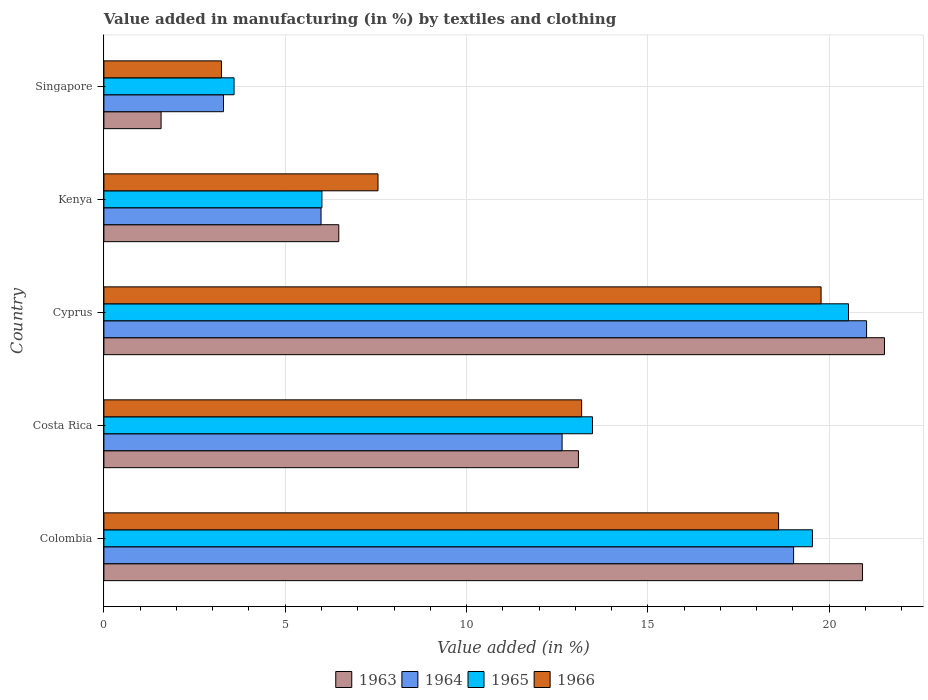How many groups of bars are there?
Your answer should be very brief. 5. Are the number of bars per tick equal to the number of legend labels?
Offer a terse response. Yes. Are the number of bars on each tick of the Y-axis equal?
Provide a succinct answer. Yes. How many bars are there on the 1st tick from the bottom?
Provide a succinct answer. 4. What is the label of the 3rd group of bars from the top?
Offer a terse response. Cyprus. What is the percentage of value added in manufacturing by textiles and clothing in 1966 in Cyprus?
Offer a terse response. 19.78. Across all countries, what is the maximum percentage of value added in manufacturing by textiles and clothing in 1965?
Your answer should be very brief. 20.53. Across all countries, what is the minimum percentage of value added in manufacturing by textiles and clothing in 1963?
Make the answer very short. 1.58. In which country was the percentage of value added in manufacturing by textiles and clothing in 1963 maximum?
Your answer should be very brief. Cyprus. In which country was the percentage of value added in manufacturing by textiles and clothing in 1965 minimum?
Make the answer very short. Singapore. What is the total percentage of value added in manufacturing by textiles and clothing in 1966 in the graph?
Your answer should be very brief. 62.35. What is the difference between the percentage of value added in manufacturing by textiles and clothing in 1965 in Costa Rica and that in Cyprus?
Keep it short and to the point. -7.06. What is the difference between the percentage of value added in manufacturing by textiles and clothing in 1966 in Kenya and the percentage of value added in manufacturing by textiles and clothing in 1965 in Cyprus?
Provide a short and direct response. -12.97. What is the average percentage of value added in manufacturing by textiles and clothing in 1963 per country?
Your response must be concise. 12.72. What is the difference between the percentage of value added in manufacturing by textiles and clothing in 1963 and percentage of value added in manufacturing by textiles and clothing in 1966 in Singapore?
Make the answer very short. -1.66. In how many countries, is the percentage of value added in manufacturing by textiles and clothing in 1966 greater than 20 %?
Offer a terse response. 0. What is the ratio of the percentage of value added in manufacturing by textiles and clothing in 1963 in Colombia to that in Cyprus?
Your answer should be compact. 0.97. Is the percentage of value added in manufacturing by textiles and clothing in 1966 in Cyprus less than that in Kenya?
Make the answer very short. No. Is the difference between the percentage of value added in manufacturing by textiles and clothing in 1963 in Costa Rica and Singapore greater than the difference between the percentage of value added in manufacturing by textiles and clothing in 1966 in Costa Rica and Singapore?
Give a very brief answer. Yes. What is the difference between the highest and the second highest percentage of value added in manufacturing by textiles and clothing in 1963?
Provide a succinct answer. 0.61. What is the difference between the highest and the lowest percentage of value added in manufacturing by textiles and clothing in 1963?
Offer a very short reply. 19.95. In how many countries, is the percentage of value added in manufacturing by textiles and clothing in 1964 greater than the average percentage of value added in manufacturing by textiles and clothing in 1964 taken over all countries?
Give a very brief answer. 3. What does the 3rd bar from the top in Kenya represents?
Offer a terse response. 1964. What does the 2nd bar from the bottom in Kenya represents?
Ensure brevity in your answer.  1964. How many bars are there?
Provide a succinct answer. 20. How many countries are there in the graph?
Make the answer very short. 5. What is the difference between two consecutive major ticks on the X-axis?
Provide a succinct answer. 5. Are the values on the major ticks of X-axis written in scientific E-notation?
Offer a very short reply. No. Does the graph contain any zero values?
Offer a very short reply. No. Where does the legend appear in the graph?
Offer a very short reply. Bottom center. How many legend labels are there?
Provide a short and direct response. 4. How are the legend labels stacked?
Offer a terse response. Horizontal. What is the title of the graph?
Your answer should be very brief. Value added in manufacturing (in %) by textiles and clothing. Does "1990" appear as one of the legend labels in the graph?
Your answer should be very brief. No. What is the label or title of the X-axis?
Provide a short and direct response. Value added (in %). What is the label or title of the Y-axis?
Your response must be concise. Country. What is the Value added (in %) of 1963 in Colombia?
Offer a very short reply. 20.92. What is the Value added (in %) in 1964 in Colombia?
Offer a terse response. 19.02. What is the Value added (in %) of 1965 in Colombia?
Make the answer very short. 19.54. What is the Value added (in %) in 1966 in Colombia?
Give a very brief answer. 18.6. What is the Value added (in %) of 1963 in Costa Rica?
Your answer should be compact. 13.08. What is the Value added (in %) in 1964 in Costa Rica?
Ensure brevity in your answer.  12.63. What is the Value added (in %) in 1965 in Costa Rica?
Provide a short and direct response. 13.47. What is the Value added (in %) of 1966 in Costa Rica?
Offer a terse response. 13.17. What is the Value added (in %) of 1963 in Cyprus?
Keep it short and to the point. 21.52. What is the Value added (in %) in 1964 in Cyprus?
Make the answer very short. 21.03. What is the Value added (in %) in 1965 in Cyprus?
Give a very brief answer. 20.53. What is the Value added (in %) in 1966 in Cyprus?
Ensure brevity in your answer.  19.78. What is the Value added (in %) in 1963 in Kenya?
Provide a succinct answer. 6.48. What is the Value added (in %) in 1964 in Kenya?
Offer a very short reply. 5.99. What is the Value added (in %) in 1965 in Kenya?
Your response must be concise. 6.01. What is the Value added (in %) of 1966 in Kenya?
Make the answer very short. 7.56. What is the Value added (in %) of 1963 in Singapore?
Keep it short and to the point. 1.58. What is the Value added (in %) in 1964 in Singapore?
Provide a succinct answer. 3.3. What is the Value added (in %) in 1965 in Singapore?
Provide a succinct answer. 3.59. What is the Value added (in %) in 1966 in Singapore?
Make the answer very short. 3.24. Across all countries, what is the maximum Value added (in %) of 1963?
Provide a succinct answer. 21.52. Across all countries, what is the maximum Value added (in %) in 1964?
Make the answer very short. 21.03. Across all countries, what is the maximum Value added (in %) of 1965?
Offer a very short reply. 20.53. Across all countries, what is the maximum Value added (in %) of 1966?
Your response must be concise. 19.78. Across all countries, what is the minimum Value added (in %) of 1963?
Give a very brief answer. 1.58. Across all countries, what is the minimum Value added (in %) in 1964?
Give a very brief answer. 3.3. Across all countries, what is the minimum Value added (in %) in 1965?
Keep it short and to the point. 3.59. Across all countries, what is the minimum Value added (in %) in 1966?
Provide a short and direct response. 3.24. What is the total Value added (in %) of 1963 in the graph?
Make the answer very short. 63.58. What is the total Value added (in %) of 1964 in the graph?
Your answer should be very brief. 61.97. What is the total Value added (in %) of 1965 in the graph?
Make the answer very short. 63.14. What is the total Value added (in %) of 1966 in the graph?
Give a very brief answer. 62.35. What is the difference between the Value added (in %) of 1963 in Colombia and that in Costa Rica?
Keep it short and to the point. 7.83. What is the difference between the Value added (in %) in 1964 in Colombia and that in Costa Rica?
Your answer should be compact. 6.38. What is the difference between the Value added (in %) of 1965 in Colombia and that in Costa Rica?
Your answer should be very brief. 6.06. What is the difference between the Value added (in %) of 1966 in Colombia and that in Costa Rica?
Give a very brief answer. 5.43. What is the difference between the Value added (in %) of 1963 in Colombia and that in Cyprus?
Your answer should be compact. -0.61. What is the difference between the Value added (in %) in 1964 in Colombia and that in Cyprus?
Your response must be concise. -2.01. What is the difference between the Value added (in %) of 1965 in Colombia and that in Cyprus?
Offer a terse response. -0.99. What is the difference between the Value added (in %) in 1966 in Colombia and that in Cyprus?
Your answer should be compact. -1.17. What is the difference between the Value added (in %) of 1963 in Colombia and that in Kenya?
Offer a very short reply. 14.44. What is the difference between the Value added (in %) in 1964 in Colombia and that in Kenya?
Offer a very short reply. 13.03. What is the difference between the Value added (in %) of 1965 in Colombia and that in Kenya?
Provide a succinct answer. 13.53. What is the difference between the Value added (in %) of 1966 in Colombia and that in Kenya?
Ensure brevity in your answer.  11.05. What is the difference between the Value added (in %) of 1963 in Colombia and that in Singapore?
Your response must be concise. 19.34. What is the difference between the Value added (in %) in 1964 in Colombia and that in Singapore?
Offer a very short reply. 15.72. What is the difference between the Value added (in %) of 1965 in Colombia and that in Singapore?
Provide a short and direct response. 15.95. What is the difference between the Value added (in %) of 1966 in Colombia and that in Singapore?
Keep it short and to the point. 15.36. What is the difference between the Value added (in %) in 1963 in Costa Rica and that in Cyprus?
Your response must be concise. -8.44. What is the difference between the Value added (in %) of 1964 in Costa Rica and that in Cyprus?
Provide a succinct answer. -8.4. What is the difference between the Value added (in %) of 1965 in Costa Rica and that in Cyprus?
Your answer should be very brief. -7.06. What is the difference between the Value added (in %) of 1966 in Costa Rica and that in Cyprus?
Give a very brief answer. -6.6. What is the difference between the Value added (in %) in 1963 in Costa Rica and that in Kenya?
Your answer should be compact. 6.61. What is the difference between the Value added (in %) of 1964 in Costa Rica and that in Kenya?
Your answer should be compact. 6.65. What is the difference between the Value added (in %) in 1965 in Costa Rica and that in Kenya?
Keep it short and to the point. 7.46. What is the difference between the Value added (in %) in 1966 in Costa Rica and that in Kenya?
Give a very brief answer. 5.62. What is the difference between the Value added (in %) in 1963 in Costa Rica and that in Singapore?
Keep it short and to the point. 11.51. What is the difference between the Value added (in %) of 1964 in Costa Rica and that in Singapore?
Offer a terse response. 9.34. What is the difference between the Value added (in %) in 1965 in Costa Rica and that in Singapore?
Your answer should be compact. 9.88. What is the difference between the Value added (in %) in 1966 in Costa Rica and that in Singapore?
Make the answer very short. 9.93. What is the difference between the Value added (in %) in 1963 in Cyprus and that in Kenya?
Offer a terse response. 15.05. What is the difference between the Value added (in %) in 1964 in Cyprus and that in Kenya?
Keep it short and to the point. 15.04. What is the difference between the Value added (in %) in 1965 in Cyprus and that in Kenya?
Provide a succinct answer. 14.52. What is the difference between the Value added (in %) of 1966 in Cyprus and that in Kenya?
Keep it short and to the point. 12.22. What is the difference between the Value added (in %) of 1963 in Cyprus and that in Singapore?
Offer a very short reply. 19.95. What is the difference between the Value added (in %) in 1964 in Cyprus and that in Singapore?
Offer a very short reply. 17.73. What is the difference between the Value added (in %) of 1965 in Cyprus and that in Singapore?
Provide a succinct answer. 16.94. What is the difference between the Value added (in %) in 1966 in Cyprus and that in Singapore?
Your answer should be compact. 16.53. What is the difference between the Value added (in %) of 1963 in Kenya and that in Singapore?
Provide a short and direct response. 4.9. What is the difference between the Value added (in %) of 1964 in Kenya and that in Singapore?
Give a very brief answer. 2.69. What is the difference between the Value added (in %) of 1965 in Kenya and that in Singapore?
Make the answer very short. 2.42. What is the difference between the Value added (in %) of 1966 in Kenya and that in Singapore?
Ensure brevity in your answer.  4.32. What is the difference between the Value added (in %) of 1963 in Colombia and the Value added (in %) of 1964 in Costa Rica?
Give a very brief answer. 8.28. What is the difference between the Value added (in %) in 1963 in Colombia and the Value added (in %) in 1965 in Costa Rica?
Your answer should be very brief. 7.44. What is the difference between the Value added (in %) of 1963 in Colombia and the Value added (in %) of 1966 in Costa Rica?
Give a very brief answer. 7.74. What is the difference between the Value added (in %) of 1964 in Colombia and the Value added (in %) of 1965 in Costa Rica?
Offer a terse response. 5.55. What is the difference between the Value added (in %) in 1964 in Colombia and the Value added (in %) in 1966 in Costa Rica?
Your response must be concise. 5.84. What is the difference between the Value added (in %) of 1965 in Colombia and the Value added (in %) of 1966 in Costa Rica?
Provide a succinct answer. 6.36. What is the difference between the Value added (in %) of 1963 in Colombia and the Value added (in %) of 1964 in Cyprus?
Your answer should be very brief. -0.11. What is the difference between the Value added (in %) in 1963 in Colombia and the Value added (in %) in 1965 in Cyprus?
Make the answer very short. 0.39. What is the difference between the Value added (in %) in 1963 in Colombia and the Value added (in %) in 1966 in Cyprus?
Keep it short and to the point. 1.14. What is the difference between the Value added (in %) in 1964 in Colombia and the Value added (in %) in 1965 in Cyprus?
Provide a succinct answer. -1.51. What is the difference between the Value added (in %) in 1964 in Colombia and the Value added (in %) in 1966 in Cyprus?
Offer a very short reply. -0.76. What is the difference between the Value added (in %) of 1965 in Colombia and the Value added (in %) of 1966 in Cyprus?
Provide a succinct answer. -0.24. What is the difference between the Value added (in %) of 1963 in Colombia and the Value added (in %) of 1964 in Kenya?
Offer a terse response. 14.93. What is the difference between the Value added (in %) of 1963 in Colombia and the Value added (in %) of 1965 in Kenya?
Provide a succinct answer. 14.91. What is the difference between the Value added (in %) in 1963 in Colombia and the Value added (in %) in 1966 in Kenya?
Offer a very short reply. 13.36. What is the difference between the Value added (in %) in 1964 in Colombia and the Value added (in %) in 1965 in Kenya?
Give a very brief answer. 13.01. What is the difference between the Value added (in %) of 1964 in Colombia and the Value added (in %) of 1966 in Kenya?
Offer a very short reply. 11.46. What is the difference between the Value added (in %) in 1965 in Colombia and the Value added (in %) in 1966 in Kenya?
Offer a very short reply. 11.98. What is the difference between the Value added (in %) of 1963 in Colombia and the Value added (in %) of 1964 in Singapore?
Provide a short and direct response. 17.62. What is the difference between the Value added (in %) of 1963 in Colombia and the Value added (in %) of 1965 in Singapore?
Make the answer very short. 17.33. What is the difference between the Value added (in %) of 1963 in Colombia and the Value added (in %) of 1966 in Singapore?
Provide a succinct answer. 17.68. What is the difference between the Value added (in %) in 1964 in Colombia and the Value added (in %) in 1965 in Singapore?
Make the answer very short. 15.43. What is the difference between the Value added (in %) in 1964 in Colombia and the Value added (in %) in 1966 in Singapore?
Provide a short and direct response. 15.78. What is the difference between the Value added (in %) in 1965 in Colombia and the Value added (in %) in 1966 in Singapore?
Offer a terse response. 16.3. What is the difference between the Value added (in %) in 1963 in Costa Rica and the Value added (in %) in 1964 in Cyprus?
Offer a terse response. -7.95. What is the difference between the Value added (in %) in 1963 in Costa Rica and the Value added (in %) in 1965 in Cyprus?
Keep it short and to the point. -7.45. What is the difference between the Value added (in %) in 1963 in Costa Rica and the Value added (in %) in 1966 in Cyprus?
Ensure brevity in your answer.  -6.69. What is the difference between the Value added (in %) of 1964 in Costa Rica and the Value added (in %) of 1965 in Cyprus?
Provide a succinct answer. -7.9. What is the difference between the Value added (in %) of 1964 in Costa Rica and the Value added (in %) of 1966 in Cyprus?
Your response must be concise. -7.14. What is the difference between the Value added (in %) of 1965 in Costa Rica and the Value added (in %) of 1966 in Cyprus?
Your answer should be compact. -6.3. What is the difference between the Value added (in %) of 1963 in Costa Rica and the Value added (in %) of 1964 in Kenya?
Offer a terse response. 7.1. What is the difference between the Value added (in %) of 1963 in Costa Rica and the Value added (in %) of 1965 in Kenya?
Give a very brief answer. 7.07. What is the difference between the Value added (in %) of 1963 in Costa Rica and the Value added (in %) of 1966 in Kenya?
Provide a succinct answer. 5.53. What is the difference between the Value added (in %) in 1964 in Costa Rica and the Value added (in %) in 1965 in Kenya?
Provide a succinct answer. 6.62. What is the difference between the Value added (in %) in 1964 in Costa Rica and the Value added (in %) in 1966 in Kenya?
Your response must be concise. 5.08. What is the difference between the Value added (in %) of 1965 in Costa Rica and the Value added (in %) of 1966 in Kenya?
Keep it short and to the point. 5.91. What is the difference between the Value added (in %) in 1963 in Costa Rica and the Value added (in %) in 1964 in Singapore?
Ensure brevity in your answer.  9.79. What is the difference between the Value added (in %) in 1963 in Costa Rica and the Value added (in %) in 1965 in Singapore?
Your answer should be very brief. 9.5. What is the difference between the Value added (in %) in 1963 in Costa Rica and the Value added (in %) in 1966 in Singapore?
Provide a short and direct response. 9.84. What is the difference between the Value added (in %) in 1964 in Costa Rica and the Value added (in %) in 1965 in Singapore?
Ensure brevity in your answer.  9.04. What is the difference between the Value added (in %) of 1964 in Costa Rica and the Value added (in %) of 1966 in Singapore?
Keep it short and to the point. 9.39. What is the difference between the Value added (in %) of 1965 in Costa Rica and the Value added (in %) of 1966 in Singapore?
Provide a short and direct response. 10.23. What is the difference between the Value added (in %) in 1963 in Cyprus and the Value added (in %) in 1964 in Kenya?
Provide a succinct answer. 15.54. What is the difference between the Value added (in %) of 1963 in Cyprus and the Value added (in %) of 1965 in Kenya?
Ensure brevity in your answer.  15.51. What is the difference between the Value added (in %) of 1963 in Cyprus and the Value added (in %) of 1966 in Kenya?
Your response must be concise. 13.97. What is the difference between the Value added (in %) of 1964 in Cyprus and the Value added (in %) of 1965 in Kenya?
Offer a very short reply. 15.02. What is the difference between the Value added (in %) in 1964 in Cyprus and the Value added (in %) in 1966 in Kenya?
Provide a succinct answer. 13.47. What is the difference between the Value added (in %) of 1965 in Cyprus and the Value added (in %) of 1966 in Kenya?
Your response must be concise. 12.97. What is the difference between the Value added (in %) of 1963 in Cyprus and the Value added (in %) of 1964 in Singapore?
Keep it short and to the point. 18.23. What is the difference between the Value added (in %) of 1963 in Cyprus and the Value added (in %) of 1965 in Singapore?
Your answer should be very brief. 17.93. What is the difference between the Value added (in %) of 1963 in Cyprus and the Value added (in %) of 1966 in Singapore?
Your answer should be very brief. 18.28. What is the difference between the Value added (in %) of 1964 in Cyprus and the Value added (in %) of 1965 in Singapore?
Give a very brief answer. 17.44. What is the difference between the Value added (in %) in 1964 in Cyprus and the Value added (in %) in 1966 in Singapore?
Your answer should be very brief. 17.79. What is the difference between the Value added (in %) of 1965 in Cyprus and the Value added (in %) of 1966 in Singapore?
Provide a succinct answer. 17.29. What is the difference between the Value added (in %) of 1963 in Kenya and the Value added (in %) of 1964 in Singapore?
Offer a very short reply. 3.18. What is the difference between the Value added (in %) of 1963 in Kenya and the Value added (in %) of 1965 in Singapore?
Provide a succinct answer. 2.89. What is the difference between the Value added (in %) of 1963 in Kenya and the Value added (in %) of 1966 in Singapore?
Ensure brevity in your answer.  3.24. What is the difference between the Value added (in %) of 1964 in Kenya and the Value added (in %) of 1965 in Singapore?
Offer a terse response. 2.4. What is the difference between the Value added (in %) of 1964 in Kenya and the Value added (in %) of 1966 in Singapore?
Your answer should be compact. 2.75. What is the difference between the Value added (in %) of 1965 in Kenya and the Value added (in %) of 1966 in Singapore?
Provide a succinct answer. 2.77. What is the average Value added (in %) of 1963 per country?
Ensure brevity in your answer.  12.72. What is the average Value added (in %) of 1964 per country?
Your answer should be very brief. 12.39. What is the average Value added (in %) of 1965 per country?
Provide a short and direct response. 12.63. What is the average Value added (in %) of 1966 per country?
Your response must be concise. 12.47. What is the difference between the Value added (in %) of 1963 and Value added (in %) of 1964 in Colombia?
Give a very brief answer. 1.9. What is the difference between the Value added (in %) of 1963 and Value added (in %) of 1965 in Colombia?
Your answer should be very brief. 1.38. What is the difference between the Value added (in %) in 1963 and Value added (in %) in 1966 in Colombia?
Ensure brevity in your answer.  2.31. What is the difference between the Value added (in %) of 1964 and Value added (in %) of 1965 in Colombia?
Your response must be concise. -0.52. What is the difference between the Value added (in %) of 1964 and Value added (in %) of 1966 in Colombia?
Provide a succinct answer. 0.41. What is the difference between the Value added (in %) of 1965 and Value added (in %) of 1966 in Colombia?
Provide a short and direct response. 0.93. What is the difference between the Value added (in %) in 1963 and Value added (in %) in 1964 in Costa Rica?
Your answer should be compact. 0.45. What is the difference between the Value added (in %) of 1963 and Value added (in %) of 1965 in Costa Rica?
Offer a very short reply. -0.39. What is the difference between the Value added (in %) of 1963 and Value added (in %) of 1966 in Costa Rica?
Your answer should be very brief. -0.09. What is the difference between the Value added (in %) of 1964 and Value added (in %) of 1965 in Costa Rica?
Provide a succinct answer. -0.84. What is the difference between the Value added (in %) of 1964 and Value added (in %) of 1966 in Costa Rica?
Your answer should be very brief. -0.54. What is the difference between the Value added (in %) in 1965 and Value added (in %) in 1966 in Costa Rica?
Your answer should be compact. 0.3. What is the difference between the Value added (in %) of 1963 and Value added (in %) of 1964 in Cyprus?
Give a very brief answer. 0.49. What is the difference between the Value added (in %) of 1963 and Value added (in %) of 1966 in Cyprus?
Your answer should be compact. 1.75. What is the difference between the Value added (in %) in 1964 and Value added (in %) in 1965 in Cyprus?
Keep it short and to the point. 0.5. What is the difference between the Value added (in %) in 1964 and Value added (in %) in 1966 in Cyprus?
Your answer should be very brief. 1.25. What is the difference between the Value added (in %) of 1965 and Value added (in %) of 1966 in Cyprus?
Keep it short and to the point. 0.76. What is the difference between the Value added (in %) in 1963 and Value added (in %) in 1964 in Kenya?
Your answer should be very brief. 0.49. What is the difference between the Value added (in %) of 1963 and Value added (in %) of 1965 in Kenya?
Ensure brevity in your answer.  0.47. What is the difference between the Value added (in %) in 1963 and Value added (in %) in 1966 in Kenya?
Offer a very short reply. -1.08. What is the difference between the Value added (in %) in 1964 and Value added (in %) in 1965 in Kenya?
Give a very brief answer. -0.02. What is the difference between the Value added (in %) in 1964 and Value added (in %) in 1966 in Kenya?
Provide a short and direct response. -1.57. What is the difference between the Value added (in %) of 1965 and Value added (in %) of 1966 in Kenya?
Your answer should be very brief. -1.55. What is the difference between the Value added (in %) of 1963 and Value added (in %) of 1964 in Singapore?
Give a very brief answer. -1.72. What is the difference between the Value added (in %) of 1963 and Value added (in %) of 1965 in Singapore?
Keep it short and to the point. -2.01. What is the difference between the Value added (in %) in 1963 and Value added (in %) in 1966 in Singapore?
Give a very brief answer. -1.66. What is the difference between the Value added (in %) in 1964 and Value added (in %) in 1965 in Singapore?
Keep it short and to the point. -0.29. What is the difference between the Value added (in %) of 1964 and Value added (in %) of 1966 in Singapore?
Offer a terse response. 0.06. What is the difference between the Value added (in %) in 1965 and Value added (in %) in 1966 in Singapore?
Your answer should be compact. 0.35. What is the ratio of the Value added (in %) in 1963 in Colombia to that in Costa Rica?
Ensure brevity in your answer.  1.6. What is the ratio of the Value added (in %) in 1964 in Colombia to that in Costa Rica?
Your answer should be very brief. 1.51. What is the ratio of the Value added (in %) of 1965 in Colombia to that in Costa Rica?
Offer a very short reply. 1.45. What is the ratio of the Value added (in %) in 1966 in Colombia to that in Costa Rica?
Ensure brevity in your answer.  1.41. What is the ratio of the Value added (in %) in 1963 in Colombia to that in Cyprus?
Your response must be concise. 0.97. What is the ratio of the Value added (in %) of 1964 in Colombia to that in Cyprus?
Your answer should be compact. 0.9. What is the ratio of the Value added (in %) in 1965 in Colombia to that in Cyprus?
Provide a short and direct response. 0.95. What is the ratio of the Value added (in %) in 1966 in Colombia to that in Cyprus?
Your answer should be very brief. 0.94. What is the ratio of the Value added (in %) in 1963 in Colombia to that in Kenya?
Your response must be concise. 3.23. What is the ratio of the Value added (in %) of 1964 in Colombia to that in Kenya?
Your answer should be very brief. 3.18. What is the ratio of the Value added (in %) of 1966 in Colombia to that in Kenya?
Give a very brief answer. 2.46. What is the ratio of the Value added (in %) of 1963 in Colombia to that in Singapore?
Provide a succinct answer. 13.26. What is the ratio of the Value added (in %) in 1964 in Colombia to that in Singapore?
Ensure brevity in your answer.  5.77. What is the ratio of the Value added (in %) in 1965 in Colombia to that in Singapore?
Your answer should be compact. 5.44. What is the ratio of the Value added (in %) of 1966 in Colombia to that in Singapore?
Make the answer very short. 5.74. What is the ratio of the Value added (in %) of 1963 in Costa Rica to that in Cyprus?
Provide a succinct answer. 0.61. What is the ratio of the Value added (in %) of 1964 in Costa Rica to that in Cyprus?
Your answer should be very brief. 0.6. What is the ratio of the Value added (in %) in 1965 in Costa Rica to that in Cyprus?
Your response must be concise. 0.66. What is the ratio of the Value added (in %) in 1966 in Costa Rica to that in Cyprus?
Keep it short and to the point. 0.67. What is the ratio of the Value added (in %) of 1963 in Costa Rica to that in Kenya?
Ensure brevity in your answer.  2.02. What is the ratio of the Value added (in %) of 1964 in Costa Rica to that in Kenya?
Make the answer very short. 2.11. What is the ratio of the Value added (in %) of 1965 in Costa Rica to that in Kenya?
Your answer should be compact. 2.24. What is the ratio of the Value added (in %) in 1966 in Costa Rica to that in Kenya?
Provide a short and direct response. 1.74. What is the ratio of the Value added (in %) in 1963 in Costa Rica to that in Singapore?
Offer a terse response. 8.3. What is the ratio of the Value added (in %) of 1964 in Costa Rica to that in Singapore?
Ensure brevity in your answer.  3.83. What is the ratio of the Value added (in %) of 1965 in Costa Rica to that in Singapore?
Your answer should be very brief. 3.75. What is the ratio of the Value added (in %) of 1966 in Costa Rica to that in Singapore?
Make the answer very short. 4.06. What is the ratio of the Value added (in %) in 1963 in Cyprus to that in Kenya?
Offer a terse response. 3.32. What is the ratio of the Value added (in %) in 1964 in Cyprus to that in Kenya?
Your answer should be compact. 3.51. What is the ratio of the Value added (in %) in 1965 in Cyprus to that in Kenya?
Keep it short and to the point. 3.42. What is the ratio of the Value added (in %) of 1966 in Cyprus to that in Kenya?
Make the answer very short. 2.62. What is the ratio of the Value added (in %) in 1963 in Cyprus to that in Singapore?
Your answer should be compact. 13.65. What is the ratio of the Value added (in %) in 1964 in Cyprus to that in Singapore?
Make the answer very short. 6.38. What is the ratio of the Value added (in %) of 1965 in Cyprus to that in Singapore?
Your answer should be compact. 5.72. What is the ratio of the Value added (in %) in 1966 in Cyprus to that in Singapore?
Provide a succinct answer. 6.1. What is the ratio of the Value added (in %) in 1963 in Kenya to that in Singapore?
Keep it short and to the point. 4.11. What is the ratio of the Value added (in %) in 1964 in Kenya to that in Singapore?
Offer a terse response. 1.82. What is the ratio of the Value added (in %) in 1965 in Kenya to that in Singapore?
Give a very brief answer. 1.67. What is the ratio of the Value added (in %) of 1966 in Kenya to that in Singapore?
Give a very brief answer. 2.33. What is the difference between the highest and the second highest Value added (in %) in 1963?
Give a very brief answer. 0.61. What is the difference between the highest and the second highest Value added (in %) of 1964?
Your answer should be very brief. 2.01. What is the difference between the highest and the second highest Value added (in %) in 1965?
Offer a terse response. 0.99. What is the difference between the highest and the second highest Value added (in %) in 1966?
Your response must be concise. 1.17. What is the difference between the highest and the lowest Value added (in %) in 1963?
Ensure brevity in your answer.  19.95. What is the difference between the highest and the lowest Value added (in %) in 1964?
Make the answer very short. 17.73. What is the difference between the highest and the lowest Value added (in %) in 1965?
Offer a terse response. 16.94. What is the difference between the highest and the lowest Value added (in %) of 1966?
Provide a succinct answer. 16.53. 